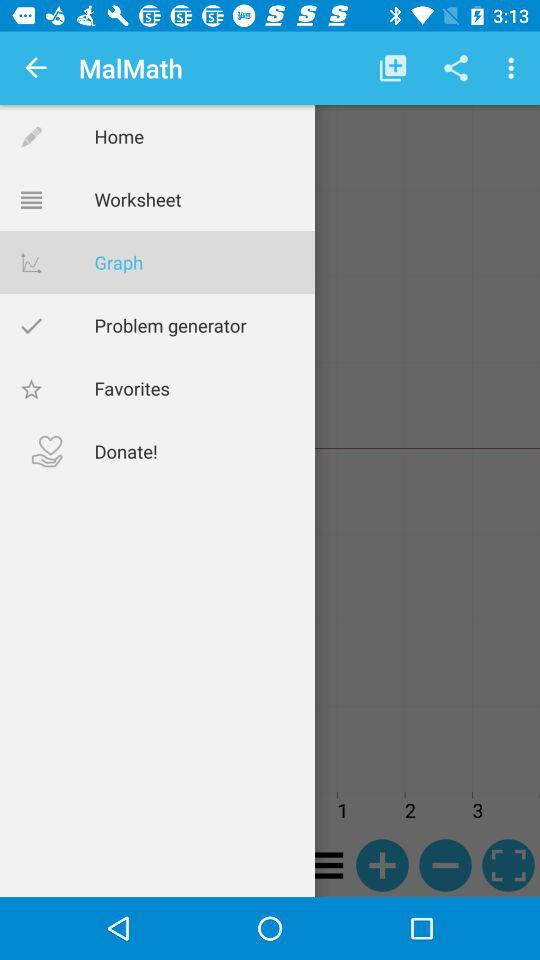What is the application name? The application name is "MalMath". 